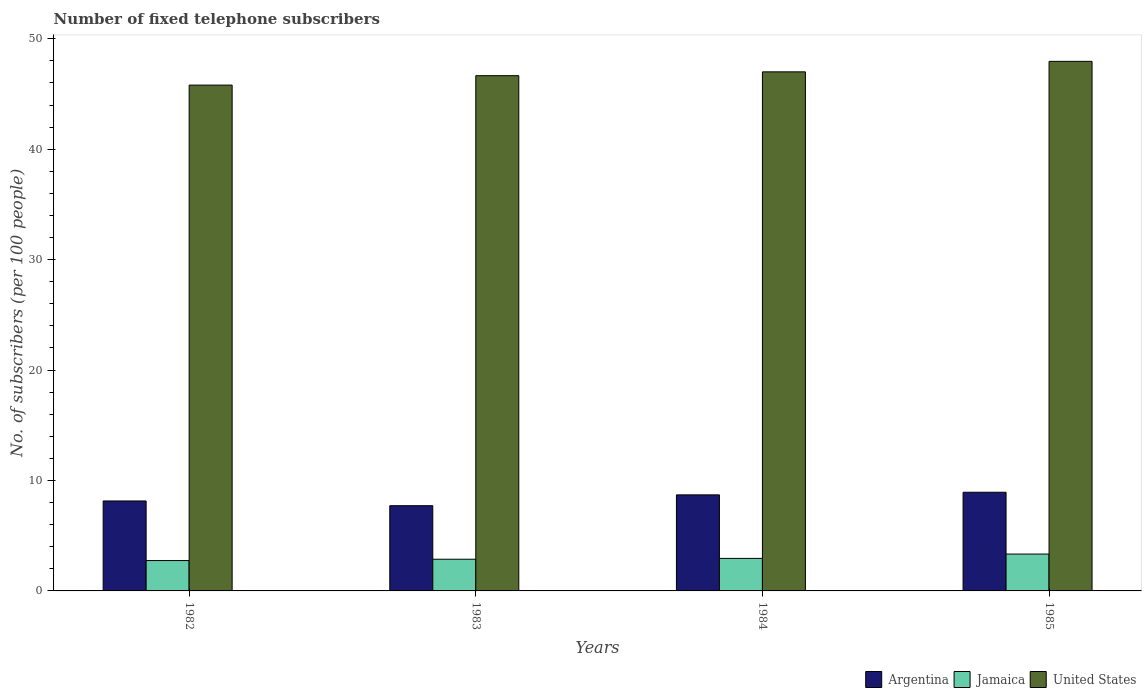How many groups of bars are there?
Give a very brief answer. 4. Are the number of bars per tick equal to the number of legend labels?
Your answer should be very brief. Yes. Are the number of bars on each tick of the X-axis equal?
Ensure brevity in your answer.  Yes. How many bars are there on the 3rd tick from the right?
Provide a succinct answer. 3. What is the label of the 3rd group of bars from the left?
Provide a succinct answer. 1984. In how many cases, is the number of bars for a given year not equal to the number of legend labels?
Keep it short and to the point. 0. What is the number of fixed telephone subscribers in United States in 1984?
Keep it short and to the point. 47. Across all years, what is the maximum number of fixed telephone subscribers in Argentina?
Offer a terse response. 8.93. Across all years, what is the minimum number of fixed telephone subscribers in Argentina?
Ensure brevity in your answer.  7.72. In which year was the number of fixed telephone subscribers in United States minimum?
Your answer should be compact. 1982. What is the total number of fixed telephone subscribers in Jamaica in the graph?
Provide a short and direct response. 11.91. What is the difference between the number of fixed telephone subscribers in Argentina in 1982 and that in 1984?
Offer a terse response. -0.55. What is the difference between the number of fixed telephone subscribers in Jamaica in 1983 and the number of fixed telephone subscribers in Argentina in 1984?
Provide a short and direct response. -5.83. What is the average number of fixed telephone subscribers in Argentina per year?
Offer a very short reply. 8.37. In the year 1985, what is the difference between the number of fixed telephone subscribers in United States and number of fixed telephone subscribers in Jamaica?
Give a very brief answer. 44.62. What is the ratio of the number of fixed telephone subscribers in Jamaica in 1983 to that in 1984?
Make the answer very short. 0.97. Is the number of fixed telephone subscribers in United States in 1983 less than that in 1985?
Make the answer very short. Yes. Is the difference between the number of fixed telephone subscribers in United States in 1982 and 1984 greater than the difference between the number of fixed telephone subscribers in Jamaica in 1982 and 1984?
Make the answer very short. No. What is the difference between the highest and the second highest number of fixed telephone subscribers in United States?
Your answer should be compact. 0.95. What is the difference between the highest and the lowest number of fixed telephone subscribers in United States?
Offer a terse response. 2.15. In how many years, is the number of fixed telephone subscribers in Argentina greater than the average number of fixed telephone subscribers in Argentina taken over all years?
Ensure brevity in your answer.  2. What does the 2nd bar from the left in 1984 represents?
Your response must be concise. Jamaica. Is it the case that in every year, the sum of the number of fixed telephone subscribers in Jamaica and number of fixed telephone subscribers in United States is greater than the number of fixed telephone subscribers in Argentina?
Your response must be concise. Yes. How many bars are there?
Your answer should be very brief. 12. Are the values on the major ticks of Y-axis written in scientific E-notation?
Your response must be concise. No. Where does the legend appear in the graph?
Ensure brevity in your answer.  Bottom right. How many legend labels are there?
Provide a succinct answer. 3. How are the legend labels stacked?
Provide a short and direct response. Horizontal. What is the title of the graph?
Offer a very short reply. Number of fixed telephone subscribers. What is the label or title of the Y-axis?
Give a very brief answer. No. of subscribers (per 100 people). What is the No. of subscribers (per 100 people) in Argentina in 1982?
Your answer should be compact. 8.15. What is the No. of subscribers (per 100 people) of Jamaica in 1982?
Make the answer very short. 2.75. What is the No. of subscribers (per 100 people) in United States in 1982?
Offer a terse response. 45.8. What is the No. of subscribers (per 100 people) of Argentina in 1983?
Offer a very short reply. 7.72. What is the No. of subscribers (per 100 people) in Jamaica in 1983?
Keep it short and to the point. 2.87. What is the No. of subscribers (per 100 people) of United States in 1983?
Ensure brevity in your answer.  46.66. What is the No. of subscribers (per 100 people) of Argentina in 1984?
Offer a very short reply. 8.7. What is the No. of subscribers (per 100 people) of Jamaica in 1984?
Your answer should be very brief. 2.95. What is the No. of subscribers (per 100 people) in United States in 1984?
Offer a terse response. 47. What is the No. of subscribers (per 100 people) of Argentina in 1985?
Provide a succinct answer. 8.93. What is the No. of subscribers (per 100 people) in Jamaica in 1985?
Ensure brevity in your answer.  3.34. What is the No. of subscribers (per 100 people) of United States in 1985?
Give a very brief answer. 47.95. Across all years, what is the maximum No. of subscribers (per 100 people) of Argentina?
Keep it short and to the point. 8.93. Across all years, what is the maximum No. of subscribers (per 100 people) of Jamaica?
Make the answer very short. 3.34. Across all years, what is the maximum No. of subscribers (per 100 people) in United States?
Provide a short and direct response. 47.95. Across all years, what is the minimum No. of subscribers (per 100 people) in Argentina?
Provide a short and direct response. 7.72. Across all years, what is the minimum No. of subscribers (per 100 people) of Jamaica?
Provide a short and direct response. 2.75. Across all years, what is the minimum No. of subscribers (per 100 people) in United States?
Make the answer very short. 45.8. What is the total No. of subscribers (per 100 people) in Argentina in the graph?
Keep it short and to the point. 33.5. What is the total No. of subscribers (per 100 people) of Jamaica in the graph?
Make the answer very short. 11.9. What is the total No. of subscribers (per 100 people) of United States in the graph?
Make the answer very short. 187.42. What is the difference between the No. of subscribers (per 100 people) of Argentina in 1982 and that in 1983?
Provide a short and direct response. 0.43. What is the difference between the No. of subscribers (per 100 people) of Jamaica in 1982 and that in 1983?
Provide a succinct answer. -0.12. What is the difference between the No. of subscribers (per 100 people) of United States in 1982 and that in 1983?
Give a very brief answer. -0.85. What is the difference between the No. of subscribers (per 100 people) in Argentina in 1982 and that in 1984?
Keep it short and to the point. -0.55. What is the difference between the No. of subscribers (per 100 people) in Jamaica in 1982 and that in 1984?
Provide a short and direct response. -0.2. What is the difference between the No. of subscribers (per 100 people) in United States in 1982 and that in 1984?
Make the answer very short. -1.2. What is the difference between the No. of subscribers (per 100 people) of Argentina in 1982 and that in 1985?
Provide a succinct answer. -0.79. What is the difference between the No. of subscribers (per 100 people) in Jamaica in 1982 and that in 1985?
Your response must be concise. -0.59. What is the difference between the No. of subscribers (per 100 people) in United States in 1982 and that in 1985?
Make the answer very short. -2.15. What is the difference between the No. of subscribers (per 100 people) in Argentina in 1983 and that in 1984?
Give a very brief answer. -0.98. What is the difference between the No. of subscribers (per 100 people) in Jamaica in 1983 and that in 1984?
Your response must be concise. -0.08. What is the difference between the No. of subscribers (per 100 people) of United States in 1983 and that in 1984?
Provide a succinct answer. -0.35. What is the difference between the No. of subscribers (per 100 people) of Argentina in 1983 and that in 1985?
Provide a succinct answer. -1.22. What is the difference between the No. of subscribers (per 100 people) of Jamaica in 1983 and that in 1985?
Provide a succinct answer. -0.47. What is the difference between the No. of subscribers (per 100 people) in United States in 1983 and that in 1985?
Make the answer very short. -1.3. What is the difference between the No. of subscribers (per 100 people) in Argentina in 1984 and that in 1985?
Offer a very short reply. -0.24. What is the difference between the No. of subscribers (per 100 people) of Jamaica in 1984 and that in 1985?
Give a very brief answer. -0.39. What is the difference between the No. of subscribers (per 100 people) in United States in 1984 and that in 1985?
Offer a very short reply. -0.95. What is the difference between the No. of subscribers (per 100 people) of Argentina in 1982 and the No. of subscribers (per 100 people) of Jamaica in 1983?
Offer a terse response. 5.27. What is the difference between the No. of subscribers (per 100 people) of Argentina in 1982 and the No. of subscribers (per 100 people) of United States in 1983?
Your response must be concise. -38.51. What is the difference between the No. of subscribers (per 100 people) in Jamaica in 1982 and the No. of subscribers (per 100 people) in United States in 1983?
Provide a short and direct response. -43.91. What is the difference between the No. of subscribers (per 100 people) of Argentina in 1982 and the No. of subscribers (per 100 people) of Jamaica in 1984?
Make the answer very short. 5.2. What is the difference between the No. of subscribers (per 100 people) in Argentina in 1982 and the No. of subscribers (per 100 people) in United States in 1984?
Keep it short and to the point. -38.86. What is the difference between the No. of subscribers (per 100 people) in Jamaica in 1982 and the No. of subscribers (per 100 people) in United States in 1984?
Make the answer very short. -44.25. What is the difference between the No. of subscribers (per 100 people) in Argentina in 1982 and the No. of subscribers (per 100 people) in Jamaica in 1985?
Make the answer very short. 4.81. What is the difference between the No. of subscribers (per 100 people) in Argentina in 1982 and the No. of subscribers (per 100 people) in United States in 1985?
Provide a succinct answer. -39.81. What is the difference between the No. of subscribers (per 100 people) of Jamaica in 1982 and the No. of subscribers (per 100 people) of United States in 1985?
Your response must be concise. -45.2. What is the difference between the No. of subscribers (per 100 people) of Argentina in 1983 and the No. of subscribers (per 100 people) of Jamaica in 1984?
Your answer should be very brief. 4.77. What is the difference between the No. of subscribers (per 100 people) in Argentina in 1983 and the No. of subscribers (per 100 people) in United States in 1984?
Offer a terse response. -39.29. What is the difference between the No. of subscribers (per 100 people) in Jamaica in 1983 and the No. of subscribers (per 100 people) in United States in 1984?
Give a very brief answer. -44.13. What is the difference between the No. of subscribers (per 100 people) in Argentina in 1983 and the No. of subscribers (per 100 people) in Jamaica in 1985?
Offer a very short reply. 4.38. What is the difference between the No. of subscribers (per 100 people) in Argentina in 1983 and the No. of subscribers (per 100 people) in United States in 1985?
Provide a succinct answer. -40.24. What is the difference between the No. of subscribers (per 100 people) in Jamaica in 1983 and the No. of subscribers (per 100 people) in United States in 1985?
Provide a short and direct response. -45.08. What is the difference between the No. of subscribers (per 100 people) in Argentina in 1984 and the No. of subscribers (per 100 people) in Jamaica in 1985?
Your answer should be very brief. 5.36. What is the difference between the No. of subscribers (per 100 people) in Argentina in 1984 and the No. of subscribers (per 100 people) in United States in 1985?
Your response must be concise. -39.26. What is the difference between the No. of subscribers (per 100 people) in Jamaica in 1984 and the No. of subscribers (per 100 people) in United States in 1985?
Your answer should be compact. -45.01. What is the average No. of subscribers (per 100 people) of Argentina per year?
Provide a succinct answer. 8.37. What is the average No. of subscribers (per 100 people) in Jamaica per year?
Offer a terse response. 2.98. What is the average No. of subscribers (per 100 people) of United States per year?
Provide a succinct answer. 46.85. In the year 1982, what is the difference between the No. of subscribers (per 100 people) of Argentina and No. of subscribers (per 100 people) of Jamaica?
Your answer should be very brief. 5.4. In the year 1982, what is the difference between the No. of subscribers (per 100 people) of Argentina and No. of subscribers (per 100 people) of United States?
Your response must be concise. -37.66. In the year 1982, what is the difference between the No. of subscribers (per 100 people) in Jamaica and No. of subscribers (per 100 people) in United States?
Your answer should be very brief. -43.05. In the year 1983, what is the difference between the No. of subscribers (per 100 people) of Argentina and No. of subscribers (per 100 people) of Jamaica?
Make the answer very short. 4.85. In the year 1983, what is the difference between the No. of subscribers (per 100 people) of Argentina and No. of subscribers (per 100 people) of United States?
Your answer should be very brief. -38.94. In the year 1983, what is the difference between the No. of subscribers (per 100 people) of Jamaica and No. of subscribers (per 100 people) of United States?
Keep it short and to the point. -43.79. In the year 1984, what is the difference between the No. of subscribers (per 100 people) of Argentina and No. of subscribers (per 100 people) of Jamaica?
Keep it short and to the point. 5.75. In the year 1984, what is the difference between the No. of subscribers (per 100 people) in Argentina and No. of subscribers (per 100 people) in United States?
Give a very brief answer. -38.3. In the year 1984, what is the difference between the No. of subscribers (per 100 people) in Jamaica and No. of subscribers (per 100 people) in United States?
Ensure brevity in your answer.  -44.06. In the year 1985, what is the difference between the No. of subscribers (per 100 people) of Argentina and No. of subscribers (per 100 people) of Jamaica?
Offer a terse response. 5.6. In the year 1985, what is the difference between the No. of subscribers (per 100 people) of Argentina and No. of subscribers (per 100 people) of United States?
Offer a terse response. -39.02. In the year 1985, what is the difference between the No. of subscribers (per 100 people) of Jamaica and No. of subscribers (per 100 people) of United States?
Make the answer very short. -44.62. What is the ratio of the No. of subscribers (per 100 people) in Argentina in 1982 to that in 1983?
Ensure brevity in your answer.  1.06. What is the ratio of the No. of subscribers (per 100 people) of Jamaica in 1982 to that in 1983?
Make the answer very short. 0.96. What is the ratio of the No. of subscribers (per 100 people) of United States in 1982 to that in 1983?
Offer a terse response. 0.98. What is the ratio of the No. of subscribers (per 100 people) of Argentina in 1982 to that in 1984?
Provide a succinct answer. 0.94. What is the ratio of the No. of subscribers (per 100 people) of Jamaica in 1982 to that in 1984?
Provide a succinct answer. 0.93. What is the ratio of the No. of subscribers (per 100 people) of United States in 1982 to that in 1984?
Keep it short and to the point. 0.97. What is the ratio of the No. of subscribers (per 100 people) of Argentina in 1982 to that in 1985?
Your answer should be compact. 0.91. What is the ratio of the No. of subscribers (per 100 people) in Jamaica in 1982 to that in 1985?
Give a very brief answer. 0.82. What is the ratio of the No. of subscribers (per 100 people) of United States in 1982 to that in 1985?
Your answer should be very brief. 0.96. What is the ratio of the No. of subscribers (per 100 people) in Argentina in 1983 to that in 1984?
Keep it short and to the point. 0.89. What is the ratio of the No. of subscribers (per 100 people) in Jamaica in 1983 to that in 1984?
Provide a short and direct response. 0.97. What is the ratio of the No. of subscribers (per 100 people) of United States in 1983 to that in 1984?
Offer a very short reply. 0.99. What is the ratio of the No. of subscribers (per 100 people) of Argentina in 1983 to that in 1985?
Provide a succinct answer. 0.86. What is the ratio of the No. of subscribers (per 100 people) of Jamaica in 1983 to that in 1985?
Make the answer very short. 0.86. What is the ratio of the No. of subscribers (per 100 people) of United States in 1983 to that in 1985?
Provide a succinct answer. 0.97. What is the ratio of the No. of subscribers (per 100 people) in Argentina in 1984 to that in 1985?
Provide a short and direct response. 0.97. What is the ratio of the No. of subscribers (per 100 people) of Jamaica in 1984 to that in 1985?
Make the answer very short. 0.88. What is the ratio of the No. of subscribers (per 100 people) in United States in 1984 to that in 1985?
Your response must be concise. 0.98. What is the difference between the highest and the second highest No. of subscribers (per 100 people) of Argentina?
Give a very brief answer. 0.24. What is the difference between the highest and the second highest No. of subscribers (per 100 people) in Jamaica?
Your response must be concise. 0.39. What is the difference between the highest and the second highest No. of subscribers (per 100 people) in United States?
Provide a succinct answer. 0.95. What is the difference between the highest and the lowest No. of subscribers (per 100 people) of Argentina?
Make the answer very short. 1.22. What is the difference between the highest and the lowest No. of subscribers (per 100 people) in Jamaica?
Make the answer very short. 0.59. What is the difference between the highest and the lowest No. of subscribers (per 100 people) in United States?
Offer a very short reply. 2.15. 